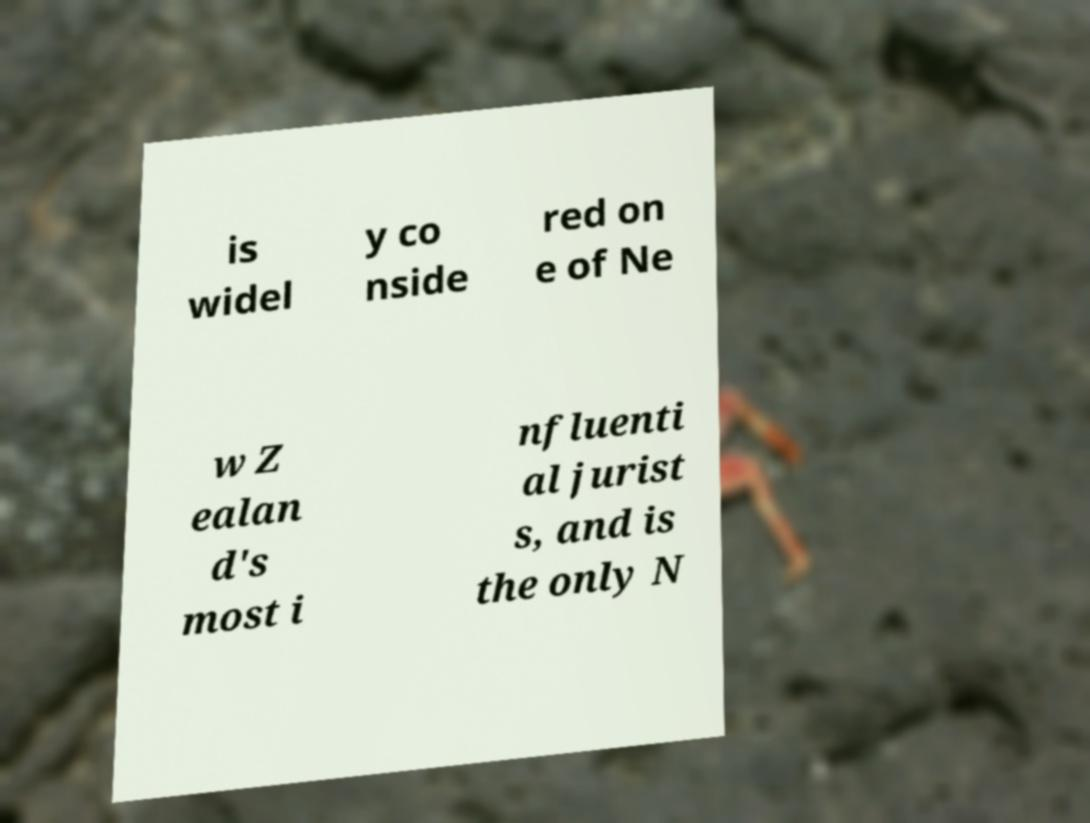What messages or text are displayed in this image? I need them in a readable, typed format. is widel y co nside red on e of Ne w Z ealan d's most i nfluenti al jurist s, and is the only N 